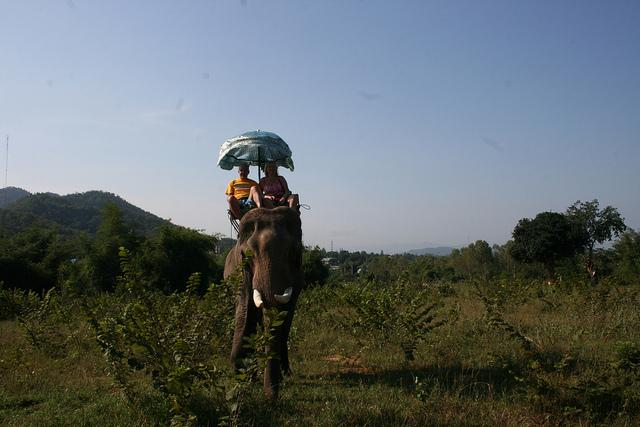What is the umbrella used to block? sun 